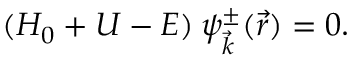<formula> <loc_0><loc_0><loc_500><loc_500>( H _ { 0 } + U - E ) \, \psi _ { \vec { k } } ^ { \pm } ( \vec { r } ) = 0 .</formula> 